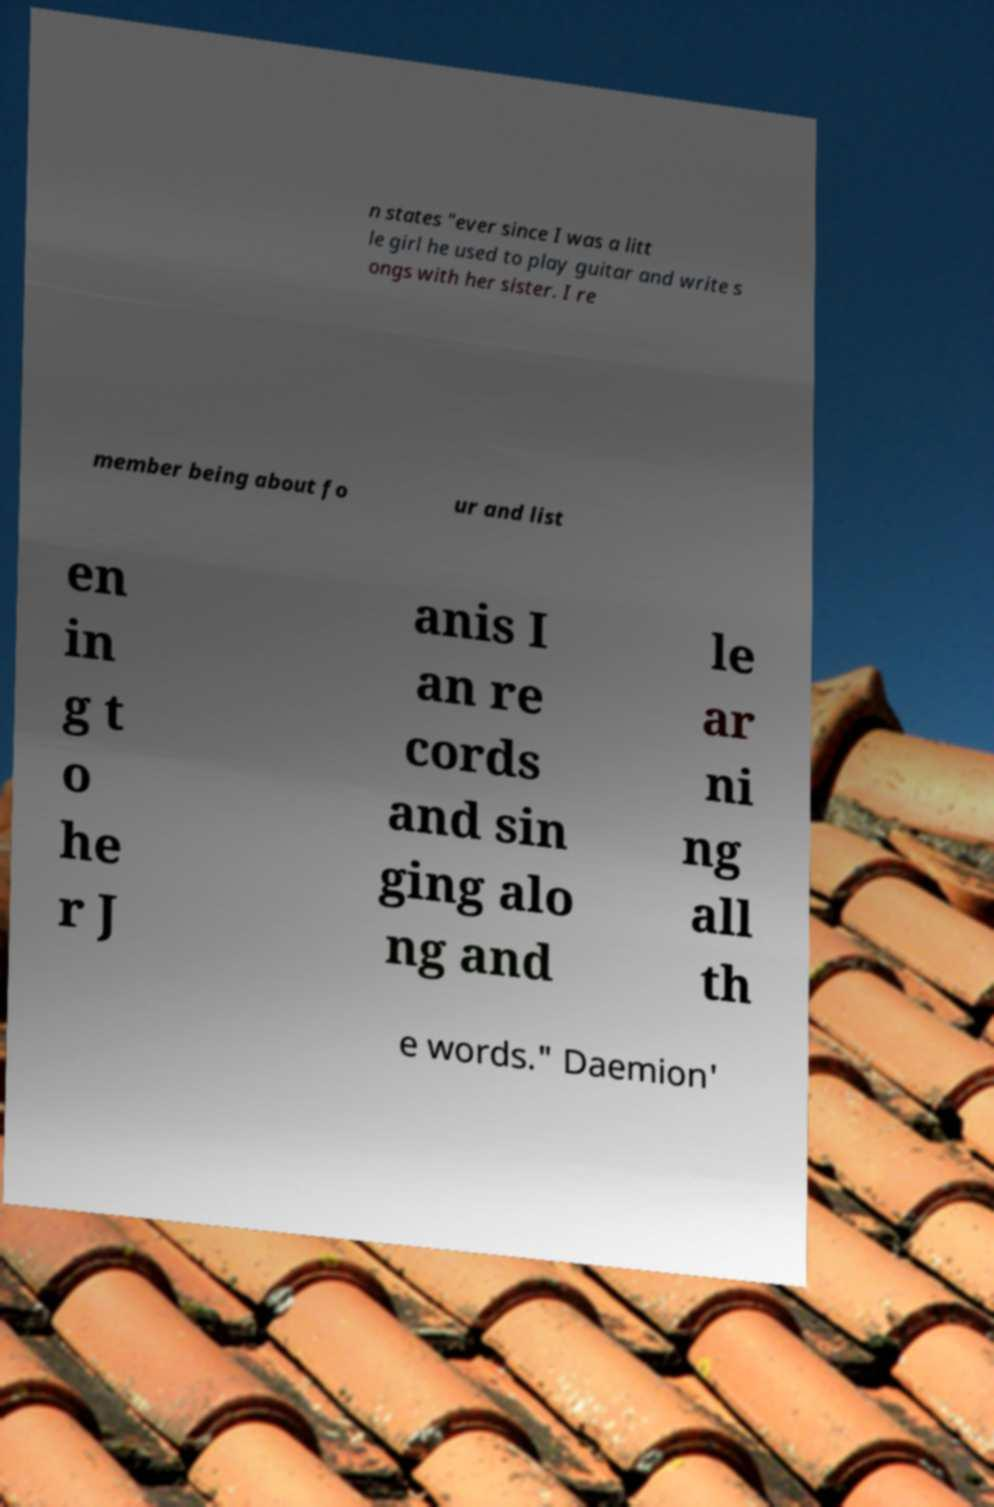There's text embedded in this image that I need extracted. Can you transcribe it verbatim? n states "ever since I was a litt le girl he used to play guitar and write s ongs with her sister. I re member being about fo ur and list en in g t o he r J anis I an re cords and sin ging alo ng and le ar ni ng all th e words." Daemion' 